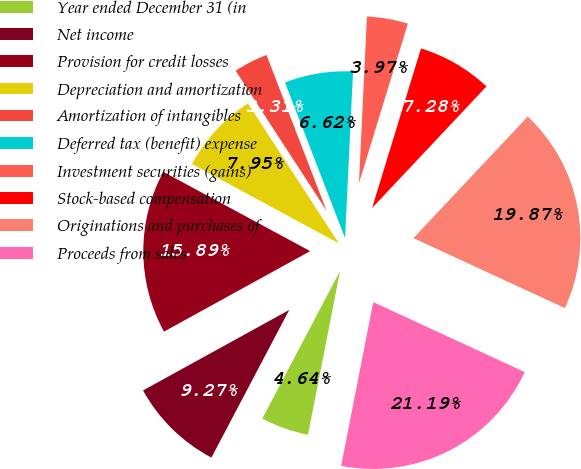Convert chart. <chart><loc_0><loc_0><loc_500><loc_500><pie_chart><fcel>Year ended December 31 (in<fcel>Net income<fcel>Provision for credit losses<fcel>Depreciation and amortization<fcel>Amortization of intangibles<fcel>Deferred tax (benefit) expense<fcel>Investment securities (gains)<fcel>Stock-based compensation<fcel>Originations and purchases of<fcel>Proceeds from sales<nl><fcel>4.64%<fcel>9.27%<fcel>15.89%<fcel>7.95%<fcel>3.31%<fcel>6.62%<fcel>3.97%<fcel>7.28%<fcel>19.87%<fcel>21.19%<nl></chart> 